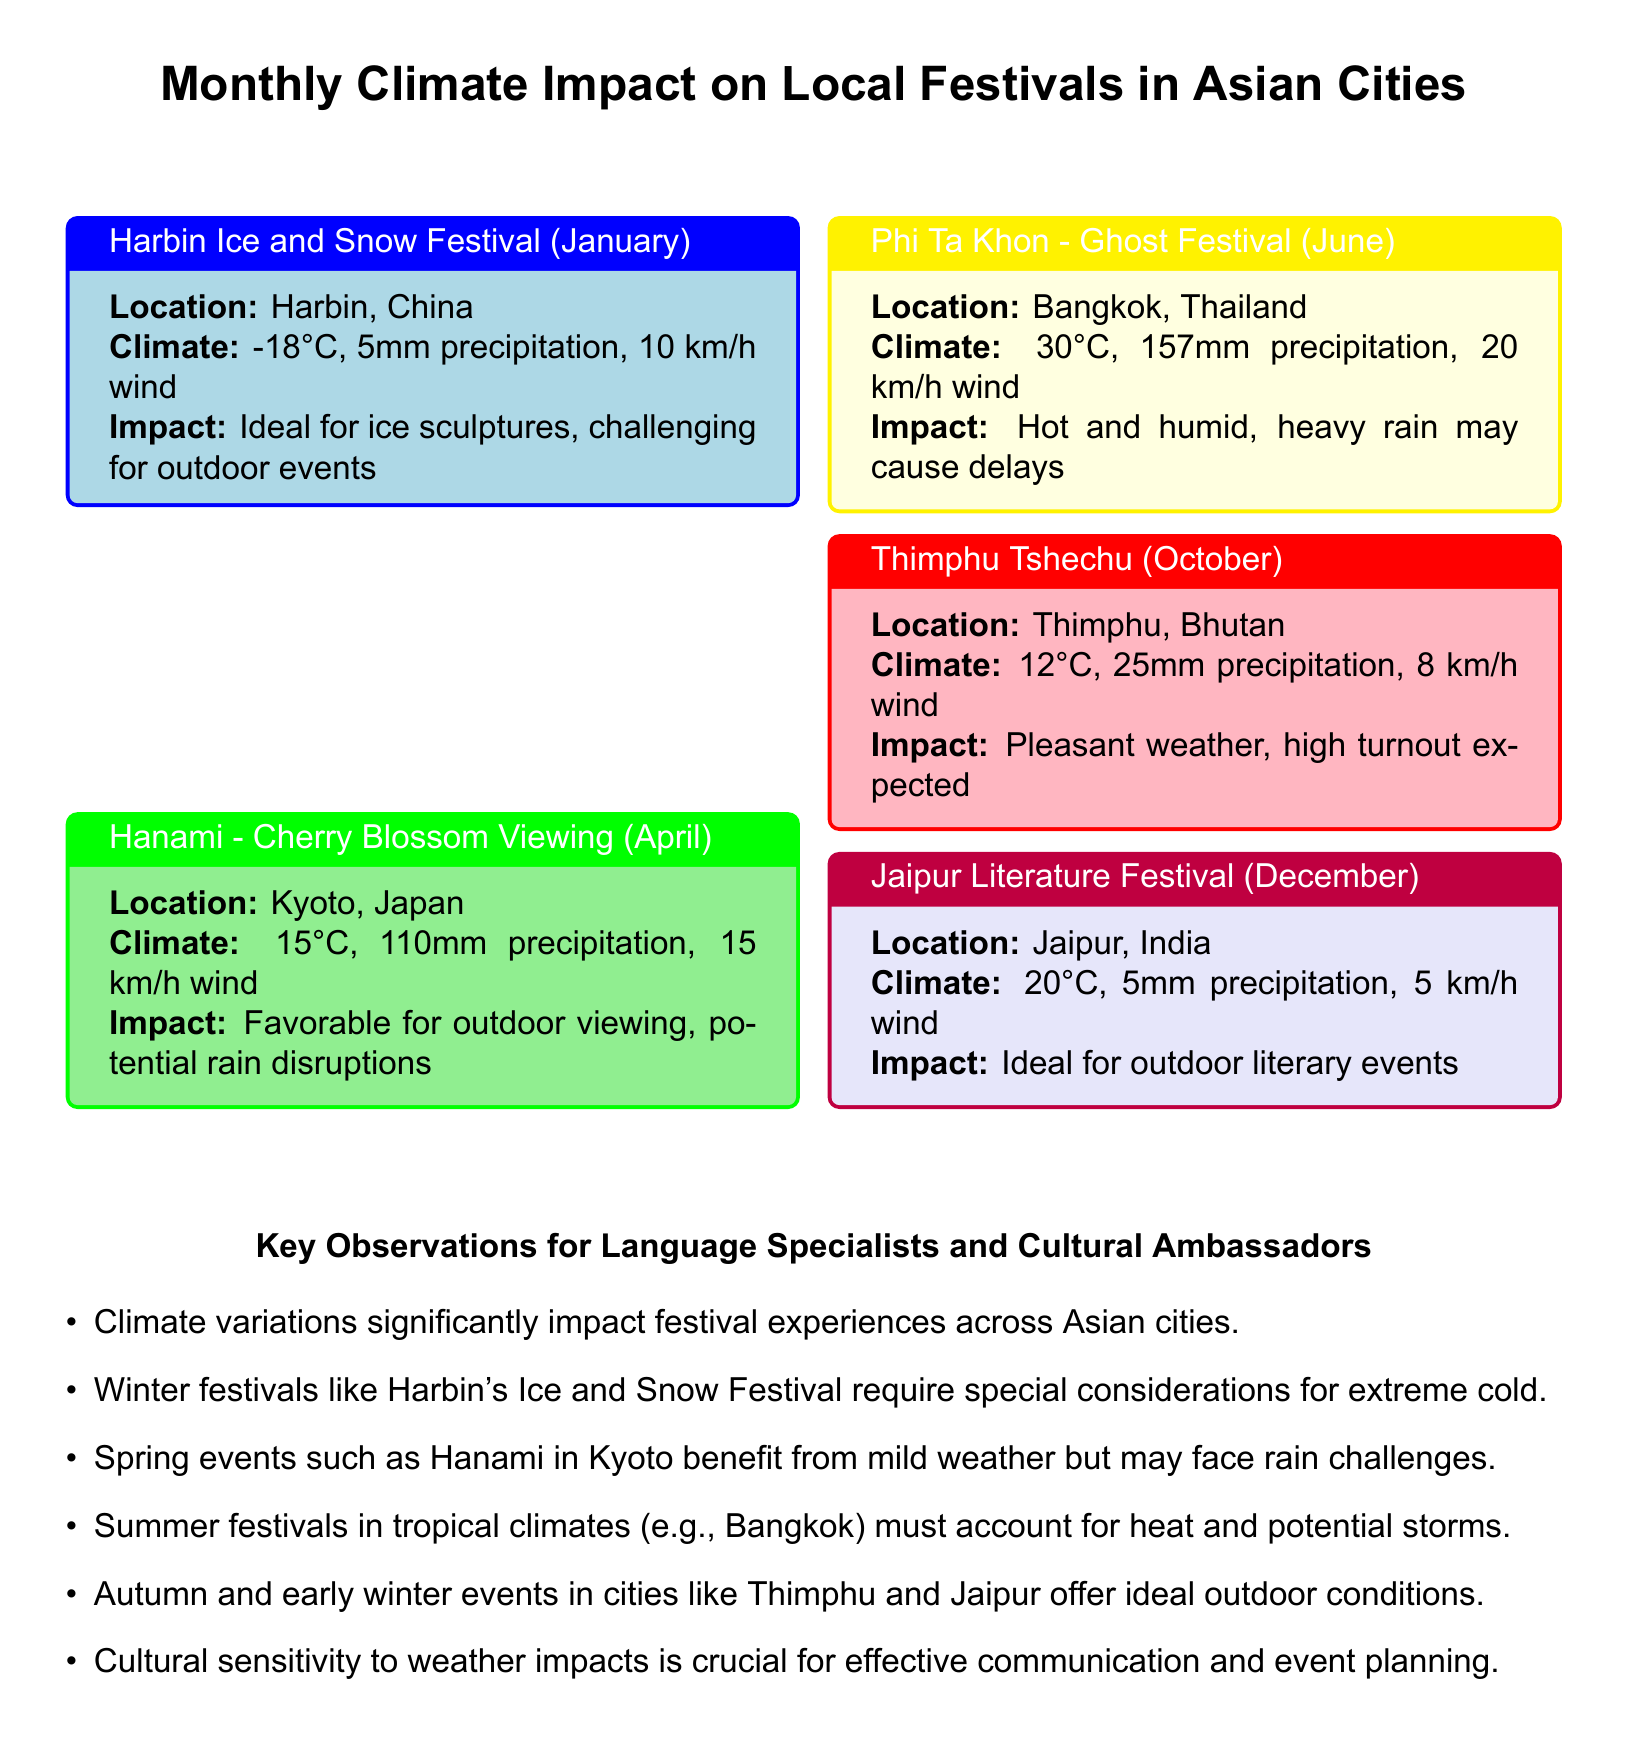what is the climate during Hanami in Kyoto? The climate for Hanami in Kyoto is characterized by a temperature of 15°C, 110mm of precipitation, and 15 km/h wind.
Answer: 15°C, 110mm precipitation, 15 km/h wind what is the impact of climate on Harbin's Ice and Snow Festival? The impact of climate on Harbin's Ice and Snow Festival is that it is ideal for ice sculptures but challenging for outdoor events due to extreme cold.
Answer: Ideal for ice sculptures, challenging for outdoor events what is the expected turnout for Thimphu Tshechu in October? The expected turnout for Thimphu Tshechu is high due to pleasant weather conditions.
Answer: High turnout expected what is the location of the Phi Ta Khon festival? The Phi Ta Khon festival takes place in Bangkok, Thailand.
Answer: Bangkok, Thailand how much precipitation is expected during the Jaipur Literature Festival? The precipitation expected during the Jaipur Literature Festival is 5mm.
Answer: 5mm what is the significance of climate variations for festival experiences? Climate variations significantly impact festival experiences across Asian cities, affecting planning and communication.
Answer: Significant impact on festival experiences how does the weather impact outdoor events in tropical climates? In tropical climates like Bangkok, the weather is hot and humid with heavy rain that may cause delays for outdoor events.
Answer: Hot and humid, heavy rain may cause delays which festival occurs in December? The festival that occurs in December is the Jaipur Literature Festival.
Answer: Jaipur Literature Festival what is the temperature during the Phi Ta Khon festival? The temperature during the Phi Ta Khon festival is 30°C.
Answer: 30°C 